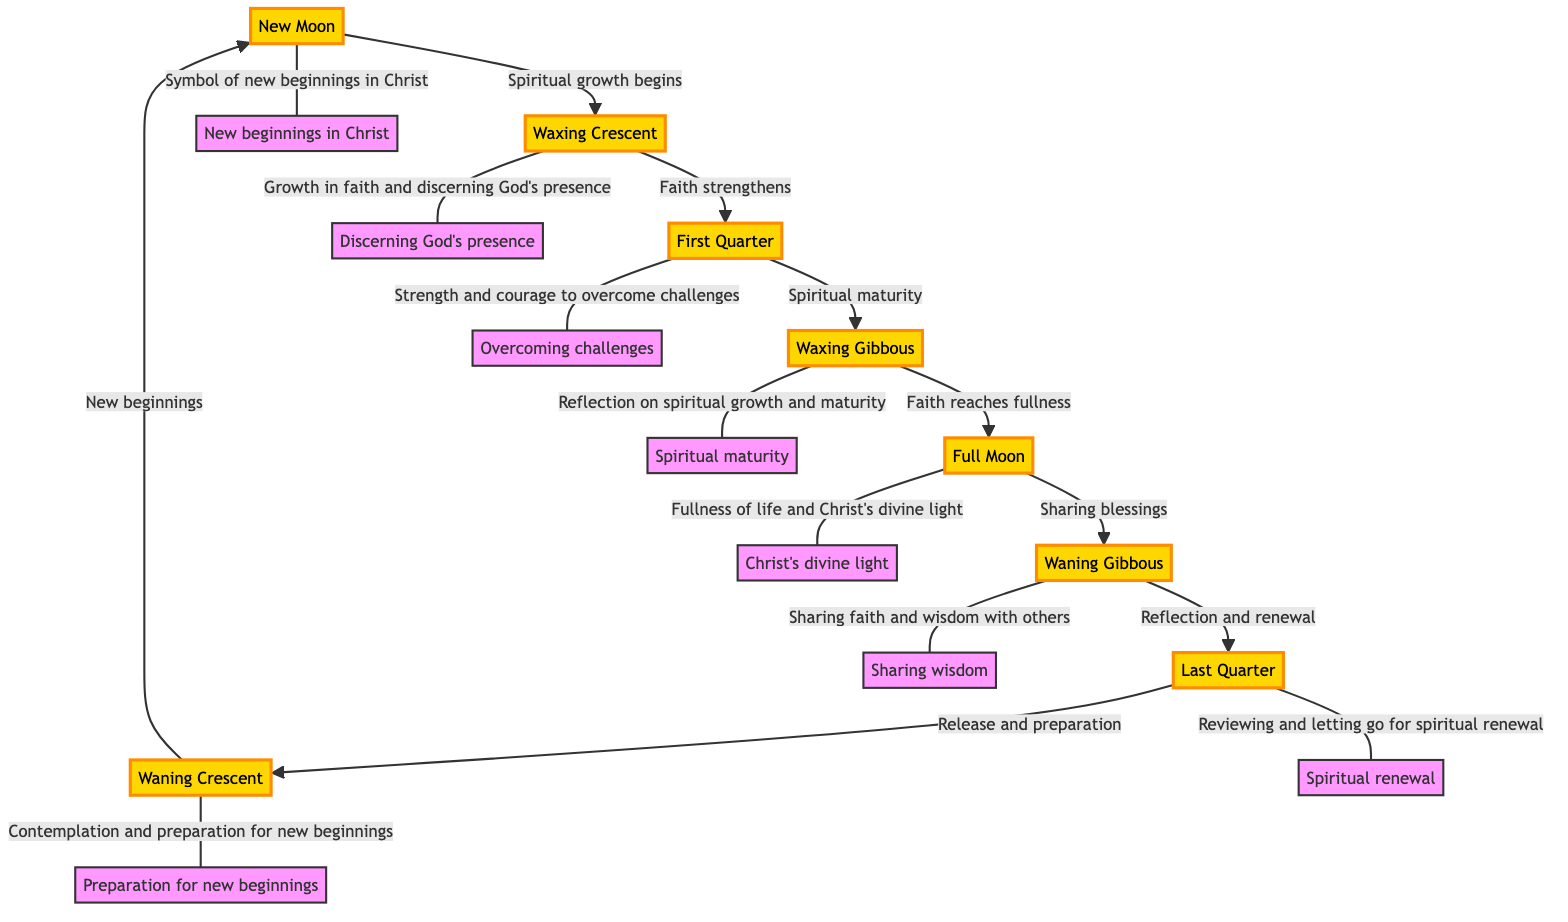What is the first phase of the moon depicted in the diagram? The diagram shows "New Moon" as the first phase, indicated by its position as the starting point in the flow.
Answer: New Moon How many phases of the moon are represented in the diagram? By counting each phase in the diagram, including New Moon, Waxing Crescent, First Quarter, Waxing Gibbous, Full Moon, Waning Gibbous, Last Quarter, and Waning Crescent, there are a total of eight phases.
Answer: 8 What spiritual concept is associated with the Full Moon phase? The diagram states that the Full Moon is associated with "Sharing blessings," connecting to the idea of fullness and abundance in faith.
Answer: Sharing blessings What is the relationship between the Last Quarter and Waning Crescent phases? The diagram shows an arrow from Last Quarter to Waning Crescent, indicating that the Last Quarter phase leads into the Waning Crescent phase.
Answer: Leads to Which phase symbolizes spiritual maturity? Referring to the diagram, "Waxing Gibbous" is the phase that symbolizes spiritual maturity according to the flow illustrated.
Answer: Waxing Gibbous What does the Waxing Crescent phase signify in terms of faith? The connection from Waxing Crescent to First Quarter in the diagram notes that this phase signifies "Faith strengthens," indicating a growth period in spiritual faith.
Answer: Faith strengthens How does the Waning Gibbous relate to reflection? The diagram indicates that the Waning Gibbous phase symbolizes "Reflection and renewal," suggesting that it is a moment for examining one’s spiritual path.
Answer: Reflection and renewal What action is associated with the New Moon in the context of Christian symbolism? The diagram states that the New Moon represents "New beginnings in Christ," highlighting its significance in the Christian faith.
Answer: New beginnings in Christ What do the arrows in the diagram represent? The arrows in the diagram indicate the flow and progression of the moon phases, showing the relationships between different phases and their associated spiritual concepts.
Answer: Progression of phases 